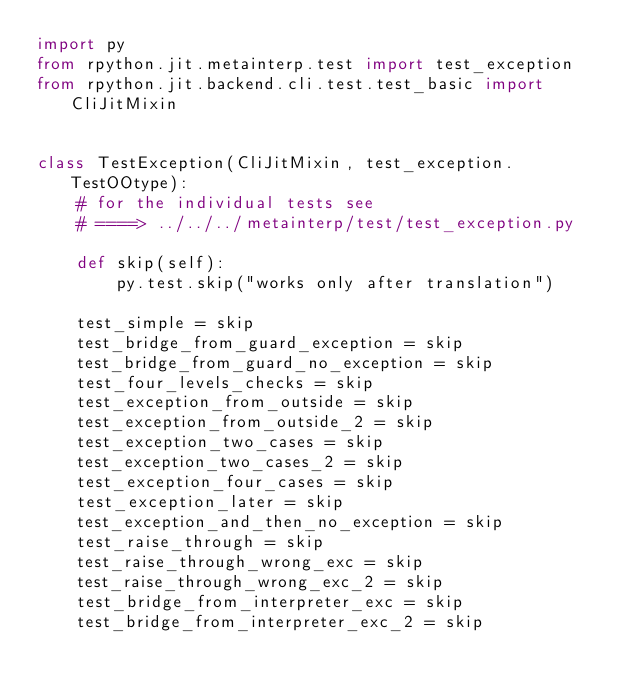Convert code to text. <code><loc_0><loc_0><loc_500><loc_500><_Python_>import py
from rpython.jit.metainterp.test import test_exception
from rpython.jit.backend.cli.test.test_basic import CliJitMixin


class TestException(CliJitMixin, test_exception.TestOOtype):
    # for the individual tests see
    # ====> ../../../metainterp/test/test_exception.py

    def skip(self):
        py.test.skip("works only after translation")

    test_simple = skip
    test_bridge_from_guard_exception = skip
    test_bridge_from_guard_no_exception = skip
    test_four_levels_checks = skip
    test_exception_from_outside = skip
    test_exception_from_outside_2 = skip
    test_exception_two_cases = skip
    test_exception_two_cases_2 = skip
    test_exception_four_cases = skip
    test_exception_later = skip
    test_exception_and_then_no_exception = skip
    test_raise_through = skip
    test_raise_through_wrong_exc = skip
    test_raise_through_wrong_exc_2 = skip
    test_bridge_from_interpreter_exc = skip
    test_bridge_from_interpreter_exc_2 = skip
</code> 